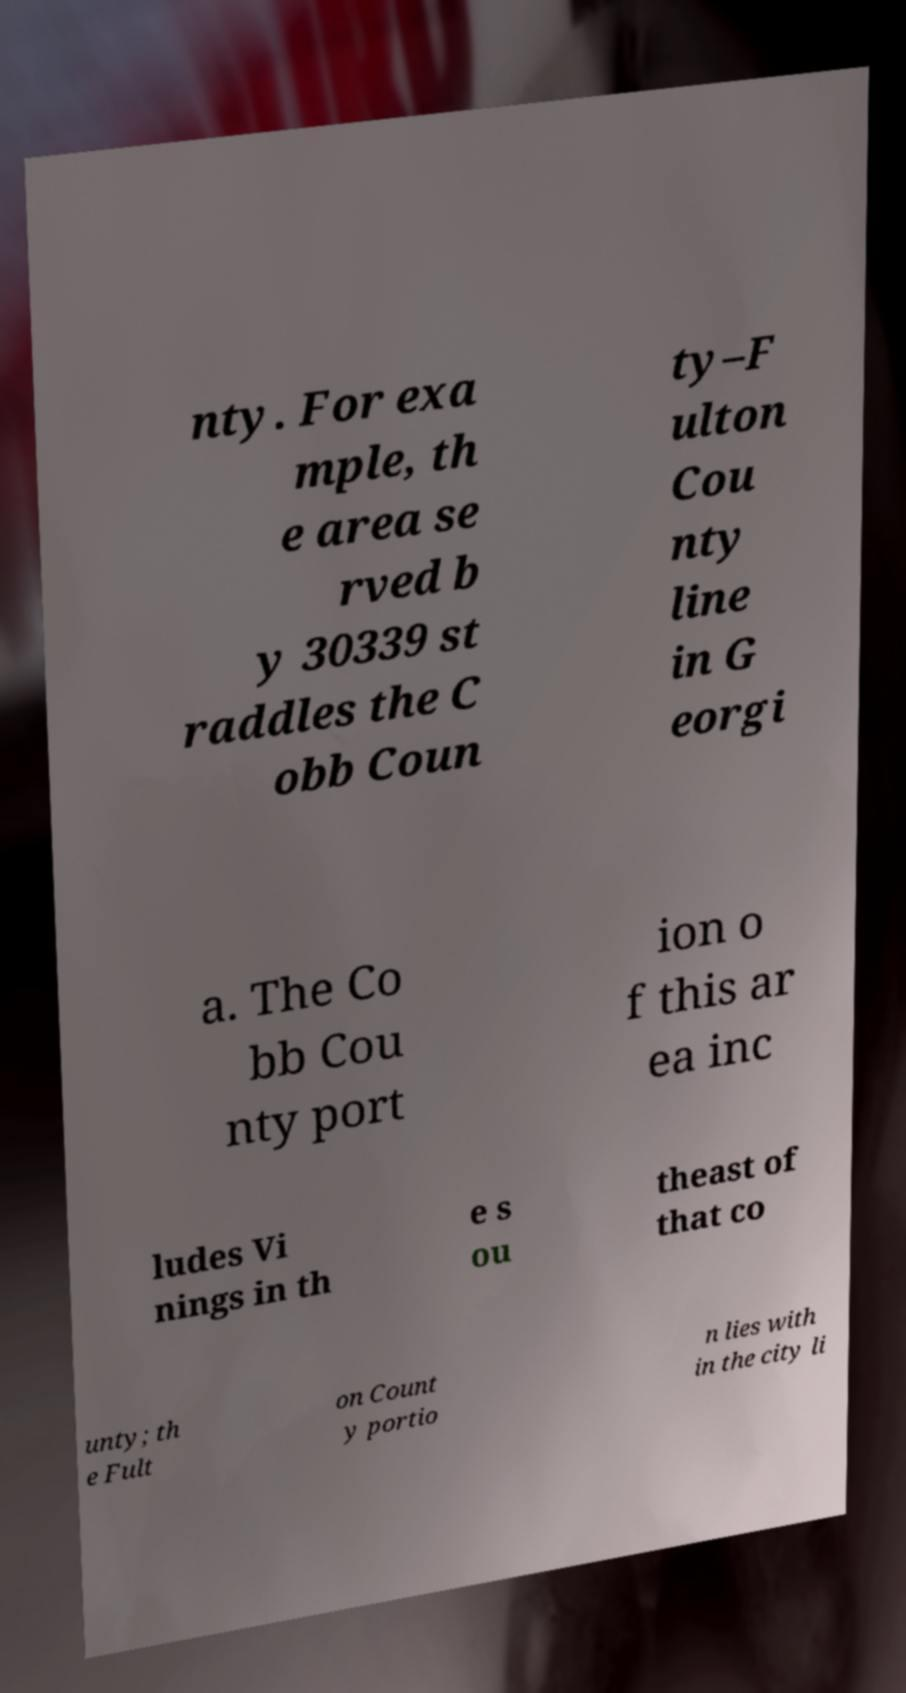Please identify and transcribe the text found in this image. nty. For exa mple, th e area se rved b y 30339 st raddles the C obb Coun ty–F ulton Cou nty line in G eorgi a. The Co bb Cou nty port ion o f this ar ea inc ludes Vi nings in th e s ou theast of that co unty; th e Fult on Count y portio n lies with in the city li 